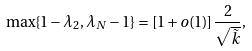Convert formula to latex. <formula><loc_0><loc_0><loc_500><loc_500>\max \{ 1 - \lambda _ { 2 } , \lambda _ { N } - 1 \} = [ 1 + o ( 1 ) ] \frac { 2 } { \sqrt { \tilde { k } } } ,</formula> 